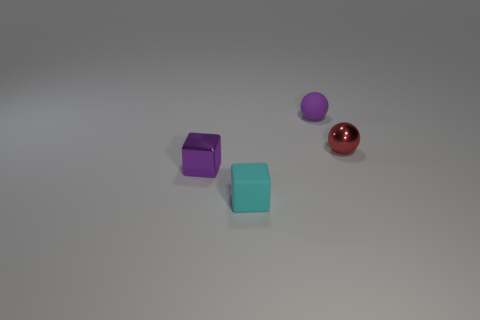Is the shiny cube the same color as the small rubber ball?
Ensure brevity in your answer.  Yes. Do the purple object in front of the shiny sphere and the cyan object have the same material?
Offer a very short reply. No. How many objects are both on the left side of the red metallic ball and behind the cyan matte cube?
Offer a very short reply. 2. There is a purple object that is to the left of the small matte object in front of the purple matte ball; what size is it?
Keep it short and to the point. Small. Are there more tiny purple rubber balls than large red blocks?
Ensure brevity in your answer.  Yes. Do the rubber object that is behind the purple block and the block that is behind the rubber block have the same color?
Make the answer very short. Yes. Are there any cyan things that are behind the tiny block that is left of the small cyan rubber thing?
Offer a very short reply. No. Is the number of tiny rubber blocks that are to the left of the cyan rubber block less than the number of purple cubes that are in front of the small rubber sphere?
Offer a very short reply. Yes. Is the small purple object in front of the red sphere made of the same material as the purple object to the right of the small purple metallic object?
Offer a terse response. No. How many tiny objects are purple metal objects or cyan metal objects?
Offer a terse response. 1. 